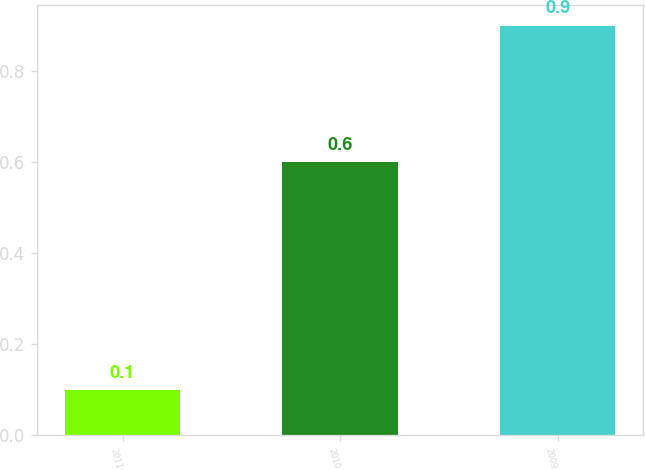Convert chart. <chart><loc_0><loc_0><loc_500><loc_500><bar_chart><fcel>2011<fcel>2010<fcel>2009<nl><fcel>0.1<fcel>0.6<fcel>0.9<nl></chart> 